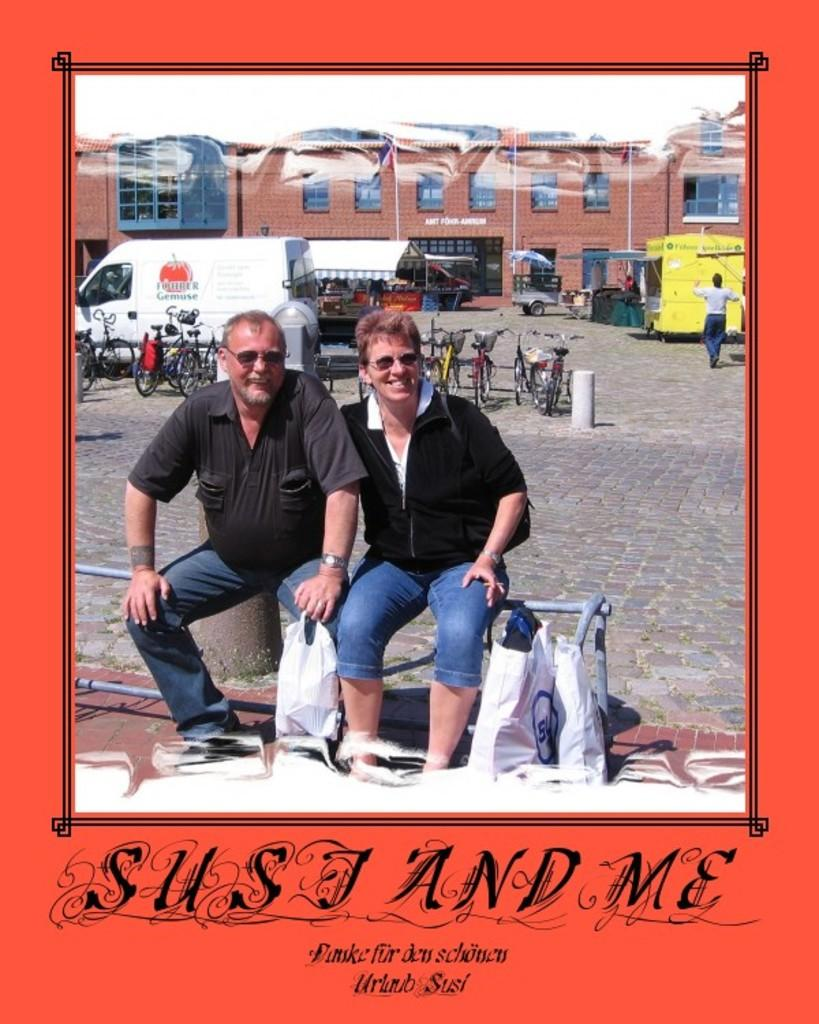<image>
Share a concise interpretation of the image provided. The title of the red book reads Susi And me 